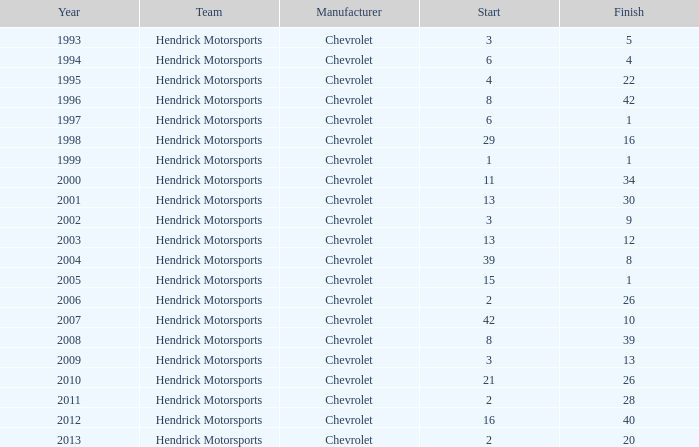Which group began with 8 years before 2008? Hendrick Motorsports. 